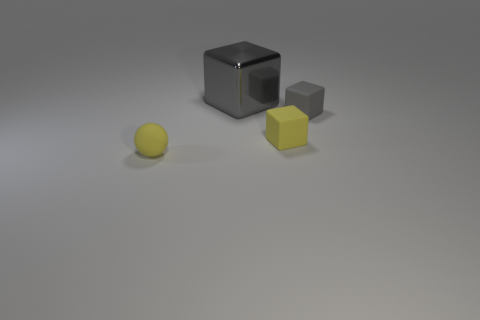Subtract all yellow rubber cubes. How many cubes are left? 2 Subtract all blue spheres. How many gray blocks are left? 2 Add 1 rubber spheres. How many objects exist? 5 Subtract all red cubes. Subtract all brown spheres. How many cubes are left? 3 Subtract all blocks. How many objects are left? 1 Subtract 1 gray cubes. How many objects are left? 3 Subtract all rubber things. Subtract all small purple matte cubes. How many objects are left? 1 Add 2 matte blocks. How many matte blocks are left? 4 Add 2 big metallic cubes. How many big metallic cubes exist? 3 